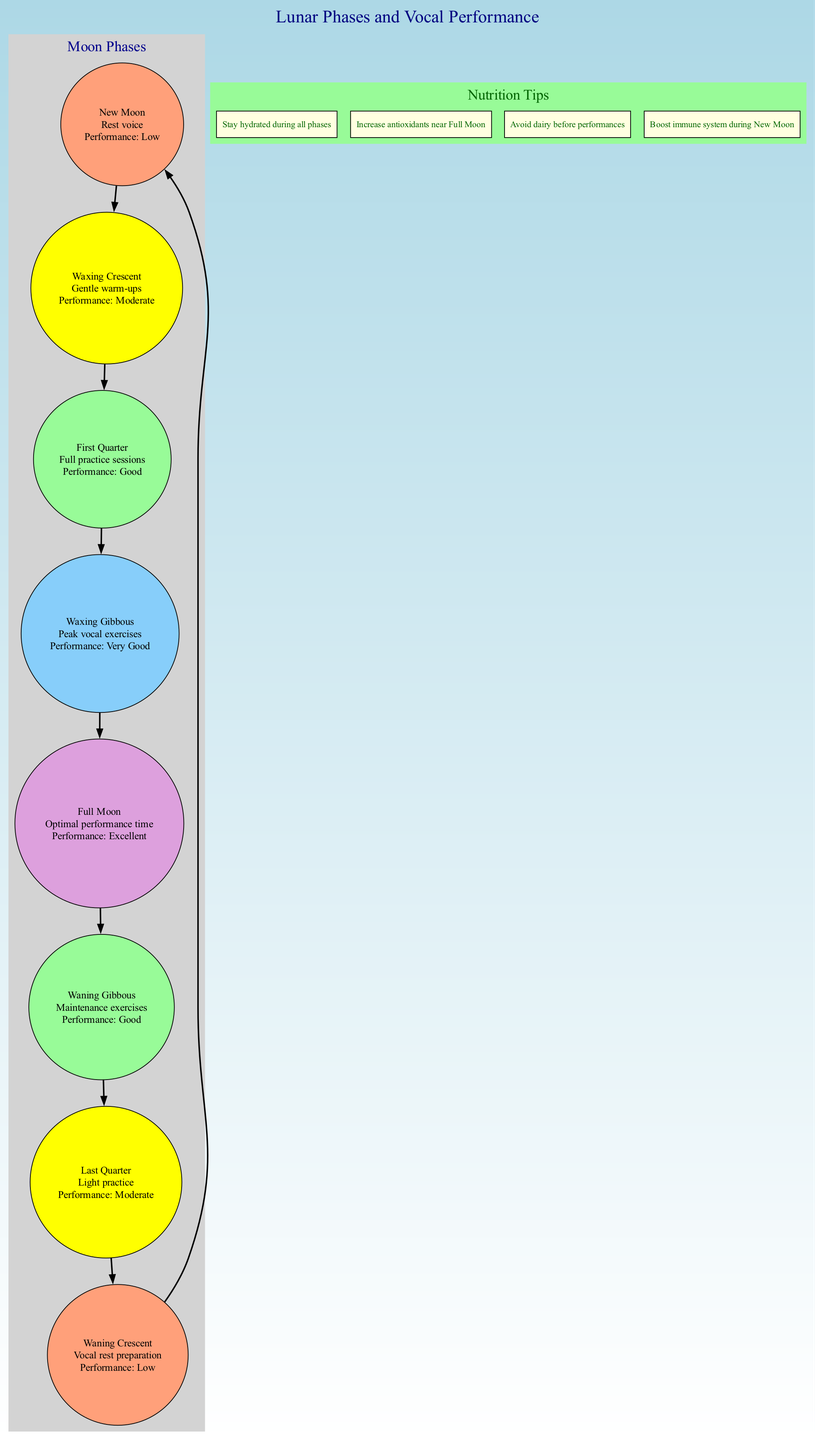What is recommended for the vocal health during the Full Moon? The diagram indicates that during the Full Moon, the recommendation is "Optimal performance time", meaning it is a peak time for vocal performance.
Answer: Optimal performance time Which phase suggests "Vocal rest preparation"? By examining the moon phases, the Waxing Crescent phase is identified as the one recommending "Vocal rest preparation".
Answer: Waxing Crescent How many moon phases are listed in the diagram? The diagram displays a total of eight distinct moon phases, which can be counted from the list provided.
Answer: 8 What is the performance suitability during the Waxing Gibbous phase? Referring to the Waxing Gibbous node, it states that the performance suitability during this phase is "Very Good".
Answer: Very Good During which phase should singers avoid dairy before performances? The diagram does not specify a phase for avoiding dairy but includes this nutrition tip. However, it's common for singers to avoid dairy prior to performances, likely aligning with the Full Moon phase for optimal performance.
Answer: Full Moon What vocal recommendation is associated with the New Moon? According to the diagram, during the New Moon phase, the vocal recommendation is "Rest voice", indicating a time for vocal recovery.
Answer: Rest voice Which phase has the highest performance suitability? By checking the performance suitability rankings in the diagram, the Full Moon is noted to have the highest suitability classified as "Excellent".
Answer: Excellent What is the vocal recommendation for the Last Quarter phase? The diagram specifies that during the Last Quarter phase, the recommendation is "Light practice".
Answer: Light practice Which nutrition tip should be followed during all phases? The diagram shows that the tip "Stay hydrated during all phases" is applicable throughout all moon phases, highlighting its importance for vocal health.
Answer: Stay hydrated during all phases 